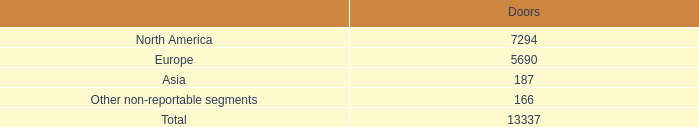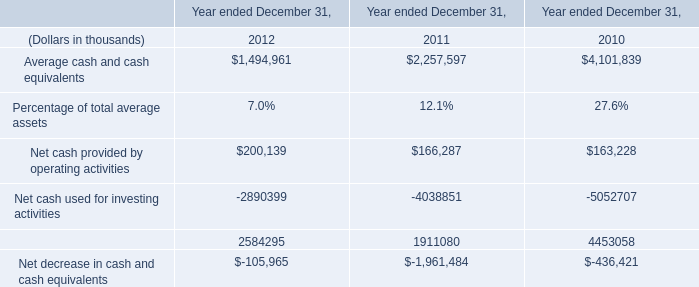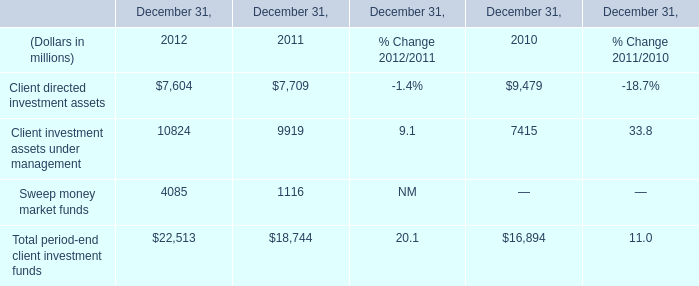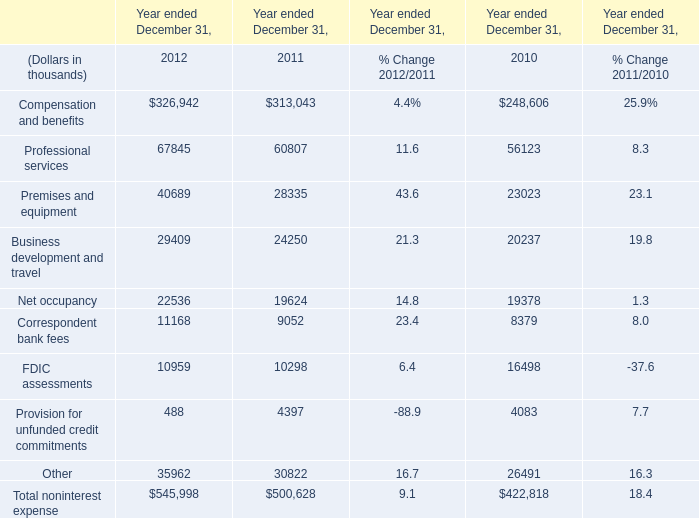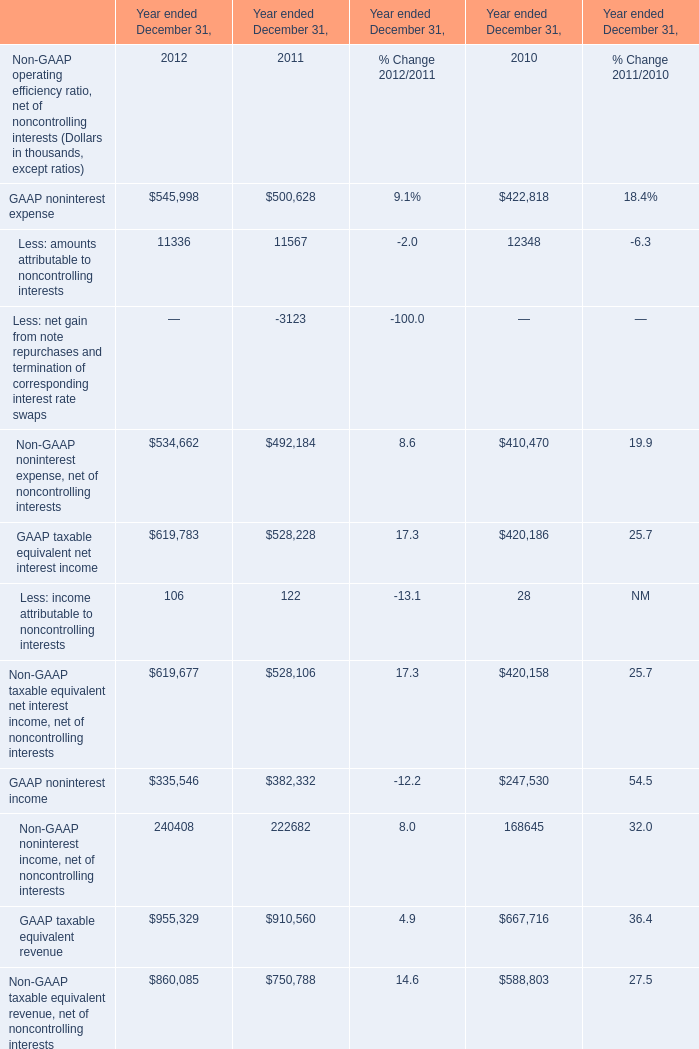what's the total amount of GAAP noninterest income of Year ended December 31, 2012, and Premises and equipment of Year ended December 31, 2011 ? 
Computations: (335546.0 + 28335.0)
Answer: 363881.0. 